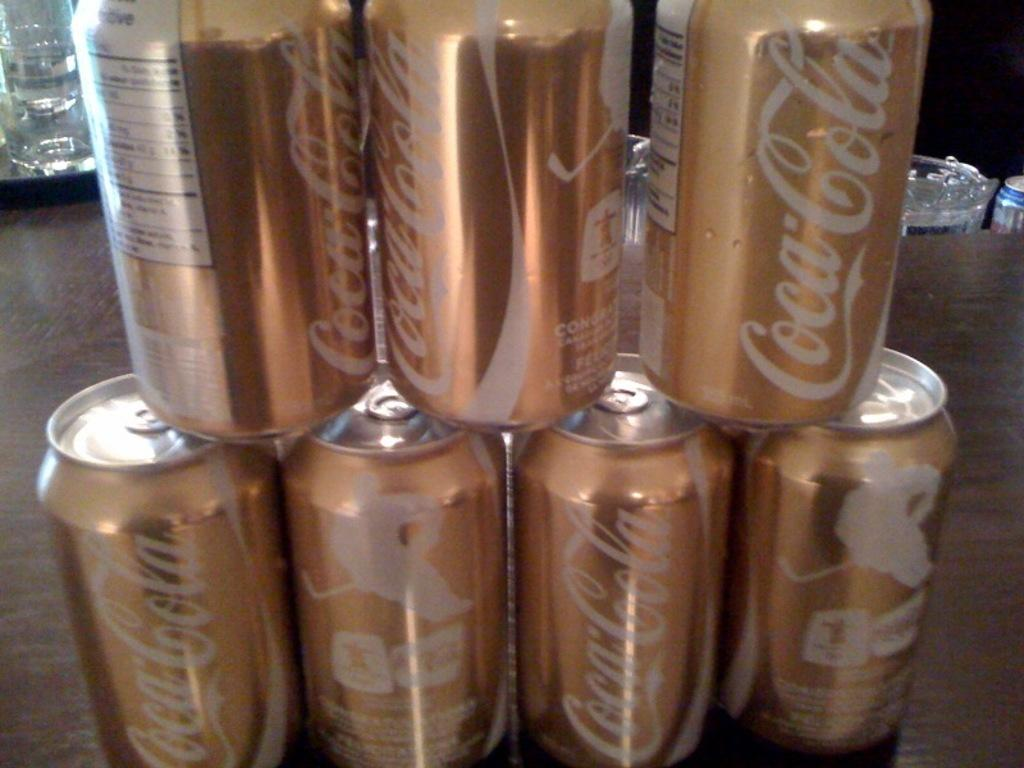<image>
Render a clear and concise summary of the photo. The coca cola cans have a gold tint to them. 